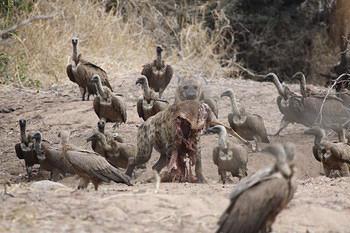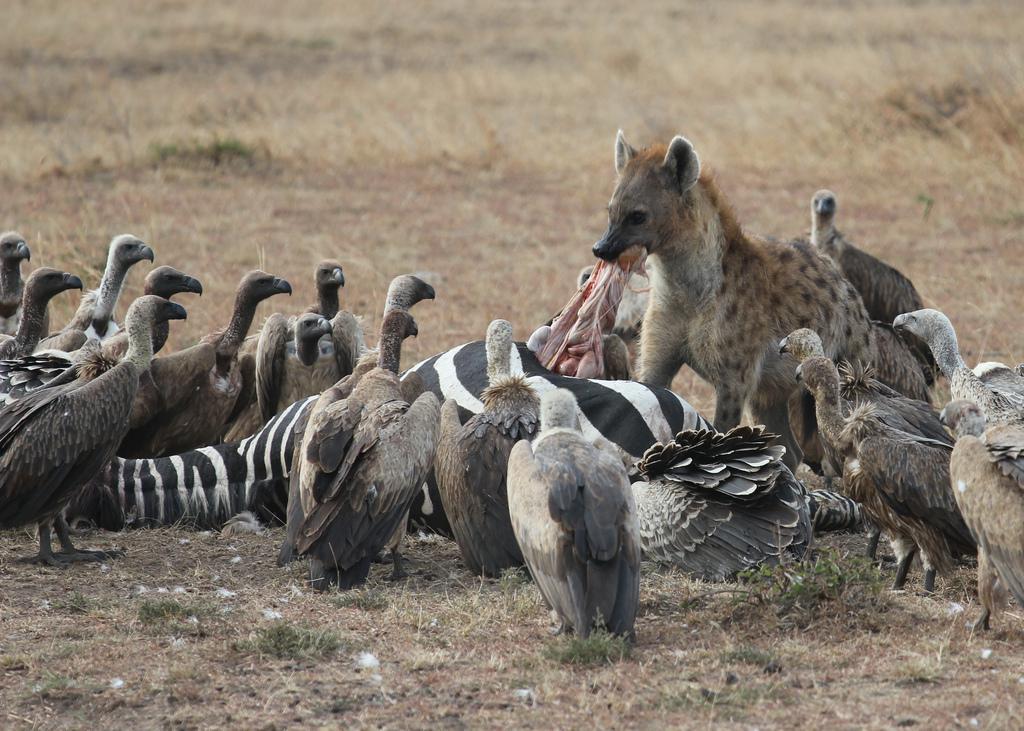The first image is the image on the left, the second image is the image on the right. Evaluate the accuracy of this statement regarding the images: "there is at least one hyena in the image on the left". Is it true? Answer yes or no. Yes. The first image is the image on the left, the second image is the image on the right. Evaluate the accuracy of this statement regarding the images: "There are a total of two hyena in the images.". Is it true? Answer yes or no. Yes. 